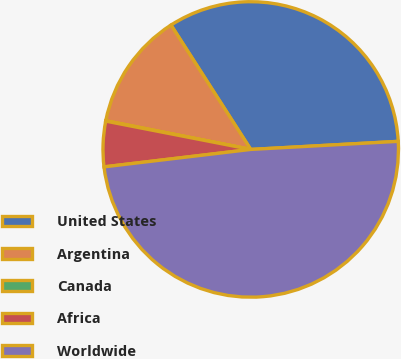Convert chart. <chart><loc_0><loc_0><loc_500><loc_500><pie_chart><fcel>United States<fcel>Argentina<fcel>Canada<fcel>Africa<fcel>Worldwide<nl><fcel>33.2%<fcel>12.81%<fcel>0.05%<fcel>4.95%<fcel>48.99%<nl></chart> 